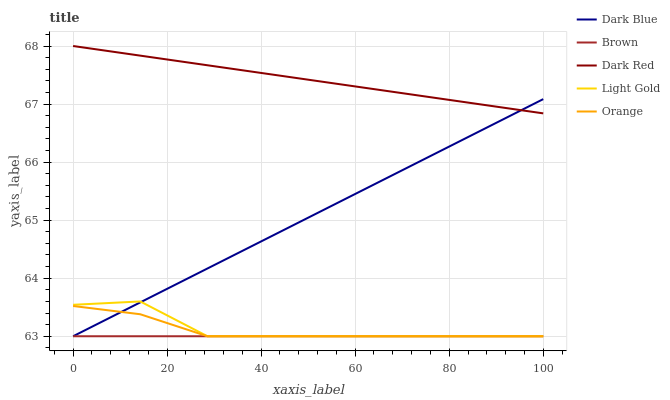Does Brown have the minimum area under the curve?
Answer yes or no. Yes. Does Dark Red have the maximum area under the curve?
Answer yes or no. Yes. Does Dark Blue have the minimum area under the curve?
Answer yes or no. No. Does Dark Blue have the maximum area under the curve?
Answer yes or no. No. Is Dark Blue the smoothest?
Answer yes or no. Yes. Is Light Gold the roughest?
Answer yes or no. Yes. Is Dark Red the smoothest?
Answer yes or no. No. Is Dark Red the roughest?
Answer yes or no. No. Does Orange have the lowest value?
Answer yes or no. Yes. Does Dark Red have the lowest value?
Answer yes or no. No. Does Dark Red have the highest value?
Answer yes or no. Yes. Does Dark Blue have the highest value?
Answer yes or no. No. Is Light Gold less than Dark Red?
Answer yes or no. Yes. Is Dark Red greater than Light Gold?
Answer yes or no. Yes. Does Brown intersect Dark Blue?
Answer yes or no. Yes. Is Brown less than Dark Blue?
Answer yes or no. No. Is Brown greater than Dark Blue?
Answer yes or no. No. Does Light Gold intersect Dark Red?
Answer yes or no. No. 